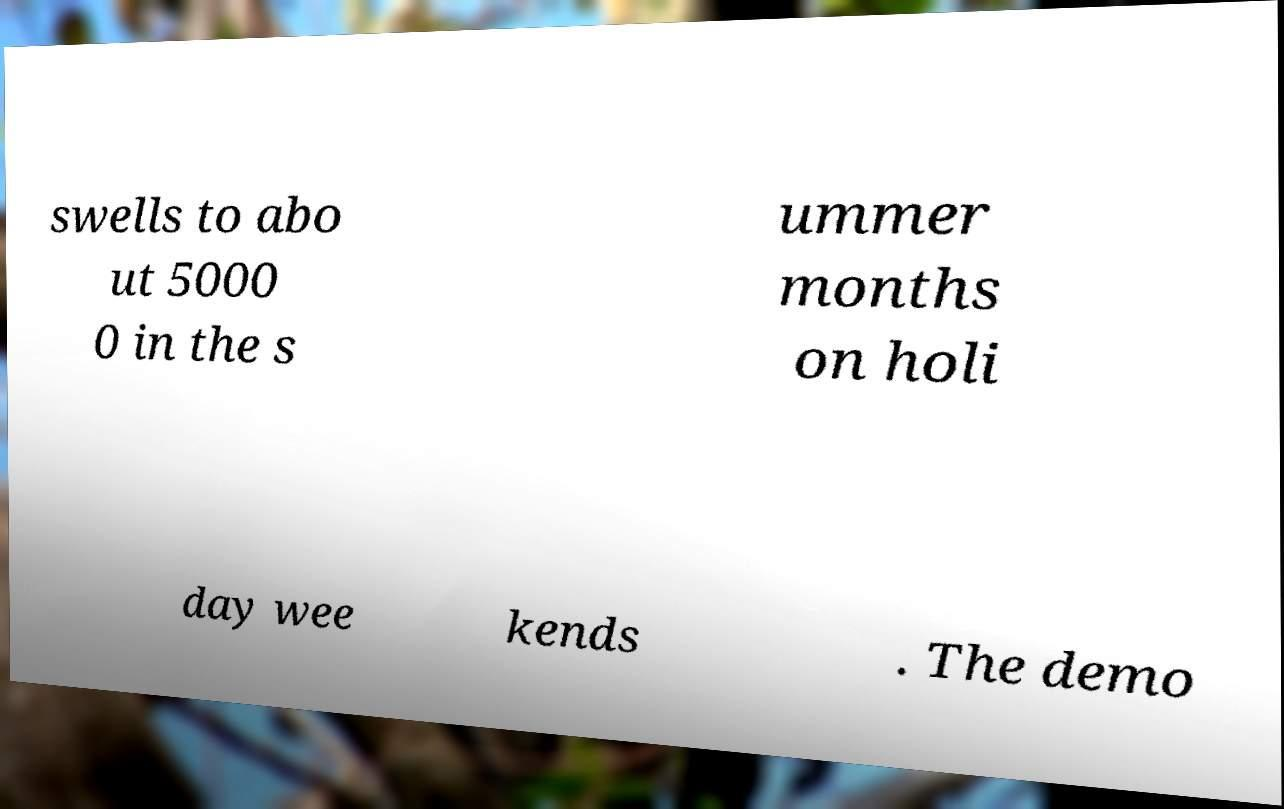There's text embedded in this image that I need extracted. Can you transcribe it verbatim? swells to abo ut 5000 0 in the s ummer months on holi day wee kends . The demo 